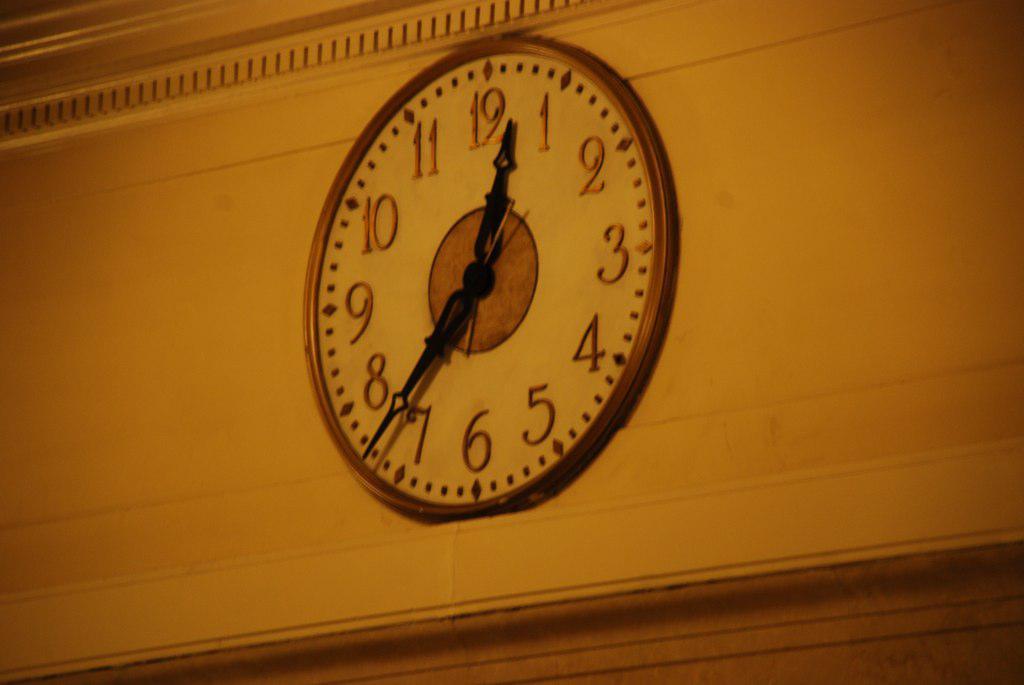What time is on the clock?
Provide a succinct answer. 12:37. Is it 3'o clock?
Provide a succinct answer. No. 